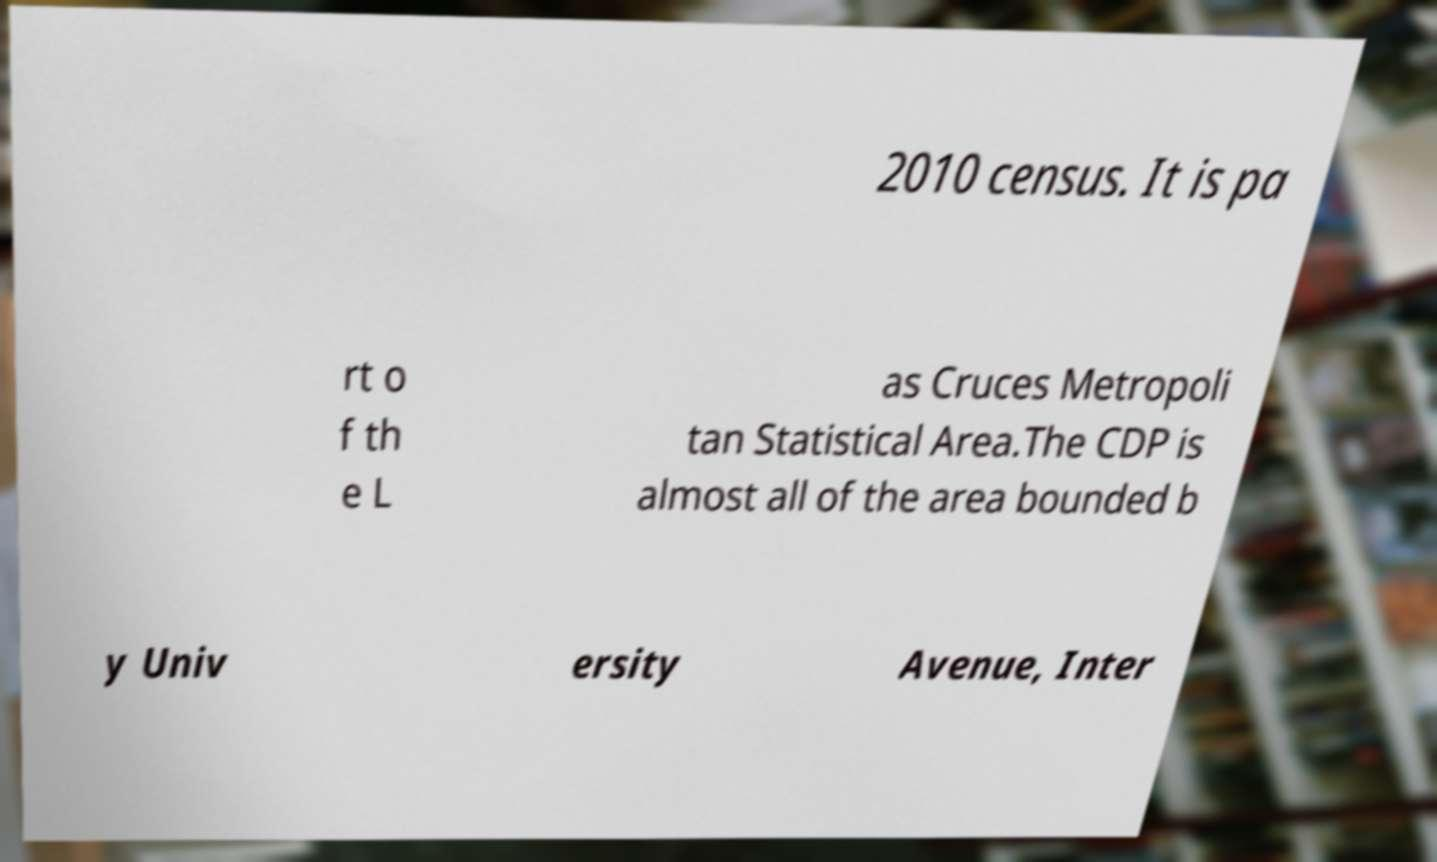Please read and relay the text visible in this image. What does it say? 2010 census. It is pa rt o f th e L as Cruces Metropoli tan Statistical Area.The CDP is almost all of the area bounded b y Univ ersity Avenue, Inter 